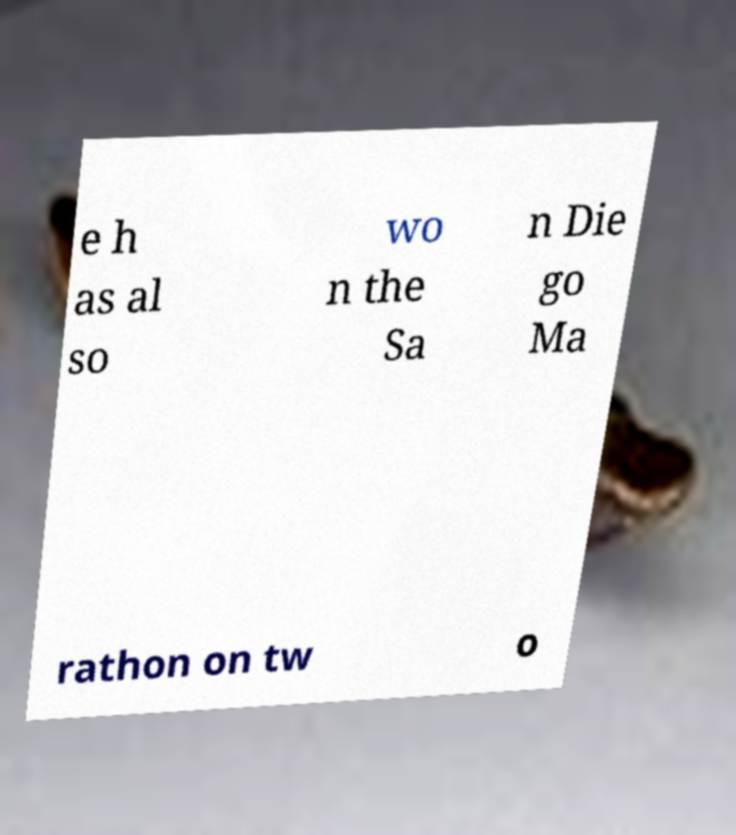Please identify and transcribe the text found in this image. e h as al so wo n the Sa n Die go Ma rathon on tw o 